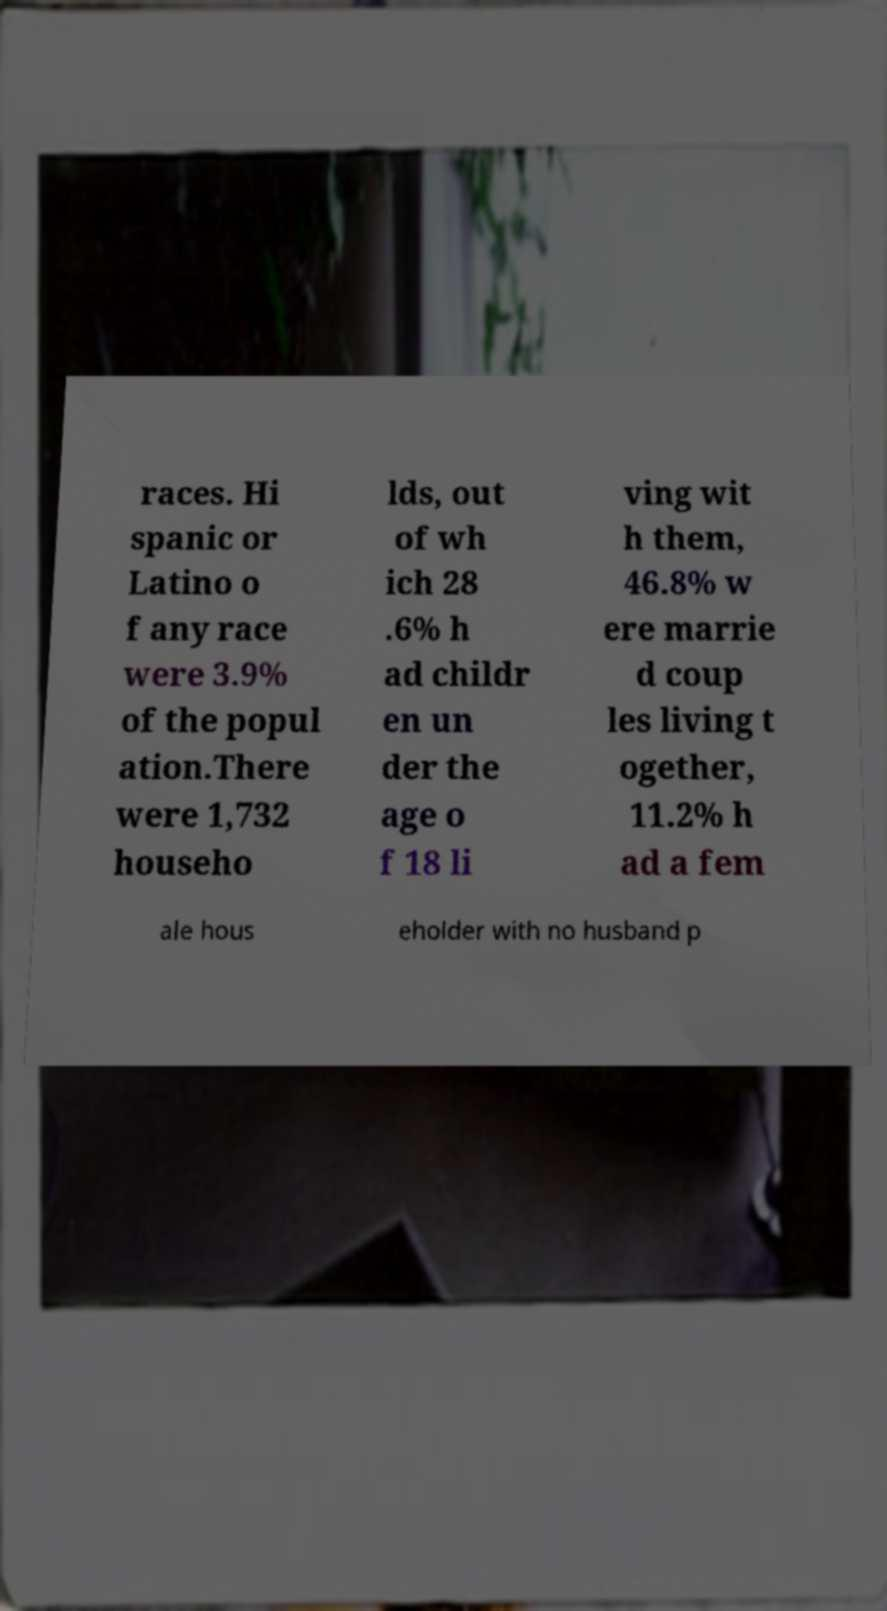Can you accurately transcribe the text from the provided image for me? races. Hi spanic or Latino o f any race were 3.9% of the popul ation.There were 1,732 househo lds, out of wh ich 28 .6% h ad childr en un der the age o f 18 li ving wit h them, 46.8% w ere marrie d coup les living t ogether, 11.2% h ad a fem ale hous eholder with no husband p 